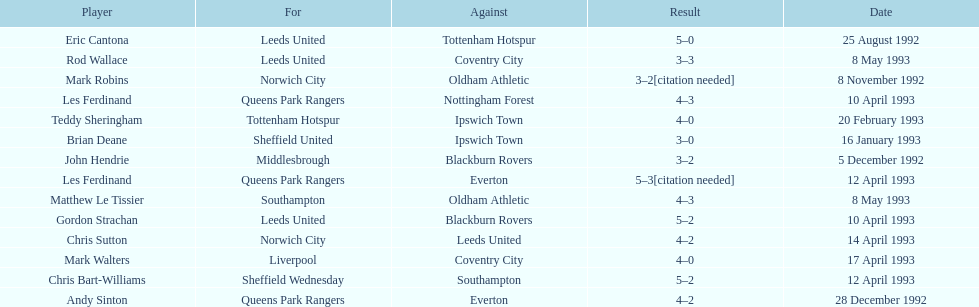What was the result of the match between queens park rangers and everton? 4-2. Could you help me parse every detail presented in this table? {'header': ['Player', 'For', 'Against', 'Result', 'Date'], 'rows': [['Eric Cantona', 'Leeds United', 'Tottenham Hotspur', '5–0', '25 August 1992'], ['Rod Wallace', 'Leeds United', 'Coventry City', '3–3', '8 May 1993'], ['Mark Robins', 'Norwich City', 'Oldham Athletic', '3–2[citation needed]', '8 November 1992'], ['Les Ferdinand', 'Queens Park Rangers', 'Nottingham Forest', '4–3', '10 April 1993'], ['Teddy Sheringham', 'Tottenham Hotspur', 'Ipswich Town', '4–0', '20 February 1993'], ['Brian Deane', 'Sheffield United', 'Ipswich Town', '3–0', '16 January 1993'], ['John Hendrie', 'Middlesbrough', 'Blackburn Rovers', '3–2', '5 December 1992'], ['Les Ferdinand', 'Queens Park Rangers', 'Everton', '5–3[citation needed]', '12 April 1993'], ['Matthew Le Tissier', 'Southampton', 'Oldham Athletic', '4–3', '8 May 1993'], ['Gordon Strachan', 'Leeds United', 'Blackburn Rovers', '5–2', '10 April 1993'], ['Chris Sutton', 'Norwich City', 'Leeds United', '4–2', '14 April 1993'], ['Mark Walters', 'Liverpool', 'Coventry City', '4–0', '17 April 1993'], ['Chris Bart-Williams', 'Sheffield Wednesday', 'Southampton', '5–2', '12 April 1993'], ['Andy Sinton', 'Queens Park Rangers', 'Everton', '4–2', '28 December 1992']]} 